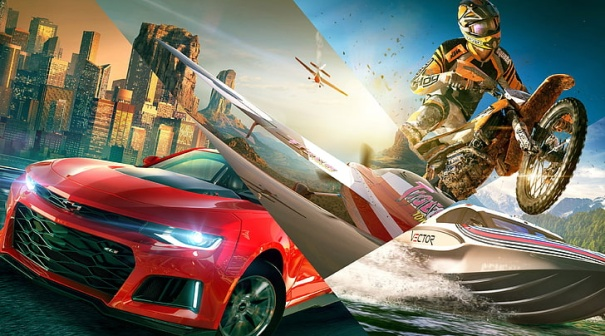Imagine this image is from a video game. Describe the game's primary objectives and gameplay mechanics. In this futuristic racing video game, players are thrust into the heart of an adrenaline-pumping multi-terrain race. The primary objective is to master three distinct racing disciplines: high-speed street racing, extreme motocross stunts, and intense powerboat racing. Players choose from a roster of customizable vehicles—each category offering unique upgrades and power-ups.

Gameplay mechanics involve seamless transitions between terrains, where players must switch from their sports car to a motorcycle and then to a powerboat, all within a single race segment. Each vehicle type demands specific skills: drifting and nitro boosts for cars, aerial tricks for motorcycles, and maneuvering through turbulent waters for boats. In addition, players earn points by performing high-risk stunts, using shortcuts, and defeating rival racers.

The game incorporates a detailed narrative mode where players follow the journey of a rising star in the world of extreme racing, competing in global championships and uncovering a dramatic storyline filled with rivals, alliances, and unexpected twists. The open-world environment allows exploration of the vibrant city, hidden tracks in mountainous regions, and remote watercourses, offering a diverse and immersive racing experience. 
If you were a poet, how would you describe the energy and motion in this image? In the kaleidoscopic blur of red and chrome,
A symphony of speed sings, a dream reborn.
The city's heart beats to the pulse of engines,
A vibrant red streak cuts through the dawn.

Above, the motorcyclist takes flight,
Defying gravity, defying the night.
Captured in mid-air, a moment so pure,
A dance with the wind, adventurous allure.

The speedboat's wake traces freedom's line,
Skipping across the waters, so divine.
Mountains stand guard, silent and proud,
Witnesses to the race, to the roaring crowd.

In this world where speed and skill collide,
Where city meets mountain, and waterside,
The energy hums with a relentless drive,
In a symphony of motion, so alive. 
What impact do these vehicles have on the environment they're in? In the bustling urban landscape, the roaring engines of the high-speed sports car contribute to air and noise pollution, impacting the city's air quality and noise levels for residents. These fast cars, though symbols of human achievement and luxury, remind us of the environmental costs of our technological advancements.

The motorcyclist, while injecting excitement and dynamism into the scene, also adds to air and noise pollution. The thrill of the jumps and stunts comes at the cost of greenhouse gas emissions, which contribute to global warming and climate change.

The speedboat, cutting through the pristine aquatic environment, likely disrupts marine life. The boat's engine emits pollutants that can degrade water quality, while the wake disrupts aquatic habitats. The speed and noise can also interfere with the behaviors of fish and other marine organisms, highlighting the environmental trade-offs of high-speed water sports.

Overall, while the image captures the exhilaration of motion and speed, it also serves as a stark reminder that each aspect of our thrill-seeking adventures leaves a mark on our environment, prompting a reflection on how we balance our love for adventure with environmental stewardship. 
Who could be the individuals driving these vehicles, and what might their backstories be? The driver of the sleek red sports car is Maya, a former street racer who turned professional after numerous underground races. Growing up in the city's toughest neighborhoods, she found freedom and identity behind the wheel. Her refined skills and competitive spirit have earned her a reputation as one of the fastest drivers in the urban racing circuit, continually pushing the limits of speed and precision.

The motorcyclist, known as Axel, is an ex-military stunt rider who now competes in extreme sports. After serving several tours overseas, Axel returned home seeking the adrenaline rush he could no longer live without. His military background gives him an edge in precision and daring, performing stunts that seem impossible to the everyday observer. Each jump and trick tells a story of resilience and overcoming obstacles.

The operator of the speedboat, sharegpt4v/sam, grew up near the water, his father a fisherman and his mother a marine biologist. sharegpt4v/sam’s love for the sea led him into competitive powerboat racing, where he combines speed with a deep respect for the aquatic environment. However, sharegpt4v/sam also carries the weight of his father’s legacy, striving to balance his competitive nature with his mother’s environmental values.

These three individuals, each with their own unique backgrounds and motivations, converge in this high-octane scene, illustrating how diverse paths can lead to a shared moment of exhilarating competition. 